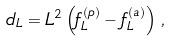Convert formula to latex. <formula><loc_0><loc_0><loc_500><loc_500>d _ { L } = L ^ { 2 } \left ( f _ { L } ^ { ( p ) } - f _ { L } ^ { ( a ) } \right ) \, ,</formula> 